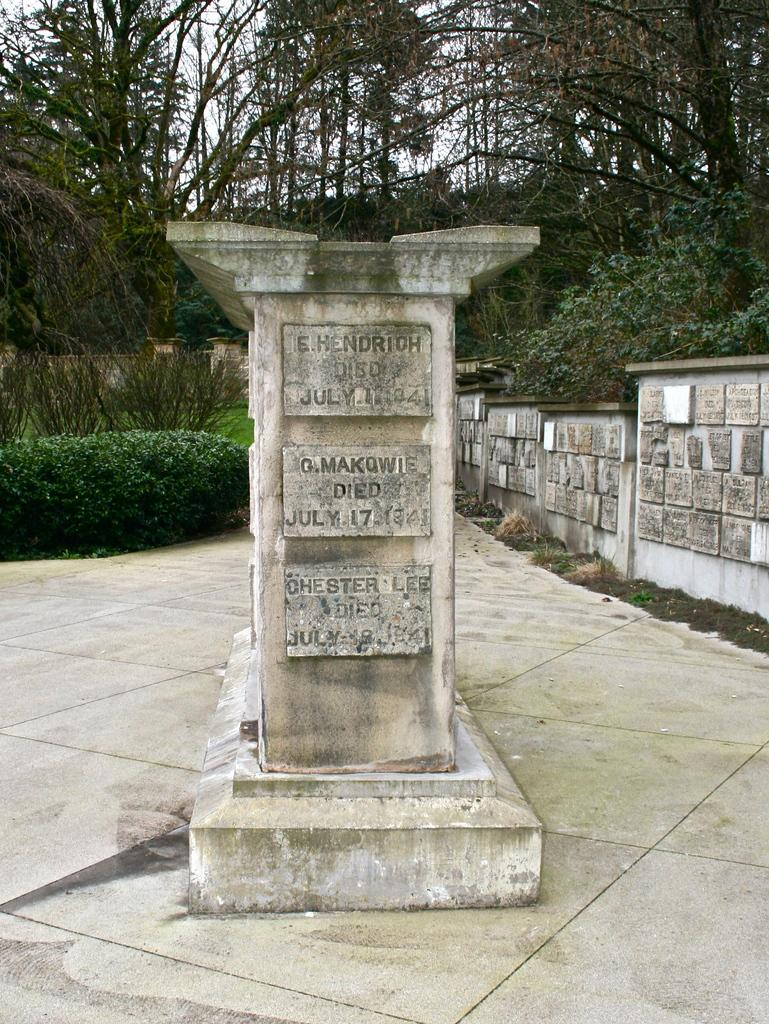What is the main subject of the image? There is a grave in the image. What is located around the grave? There is a wall surrounding the grave. What can be seen in the background of the image? There are trees in the background of the image. How many servants are standing next to the grave in the image? There are no servants present in the image. Is anyone wearing boots in the image? There is no information about footwear in the image. Can you see anyone swimming in the image? There is no water or swimming activity depicted in the image. 